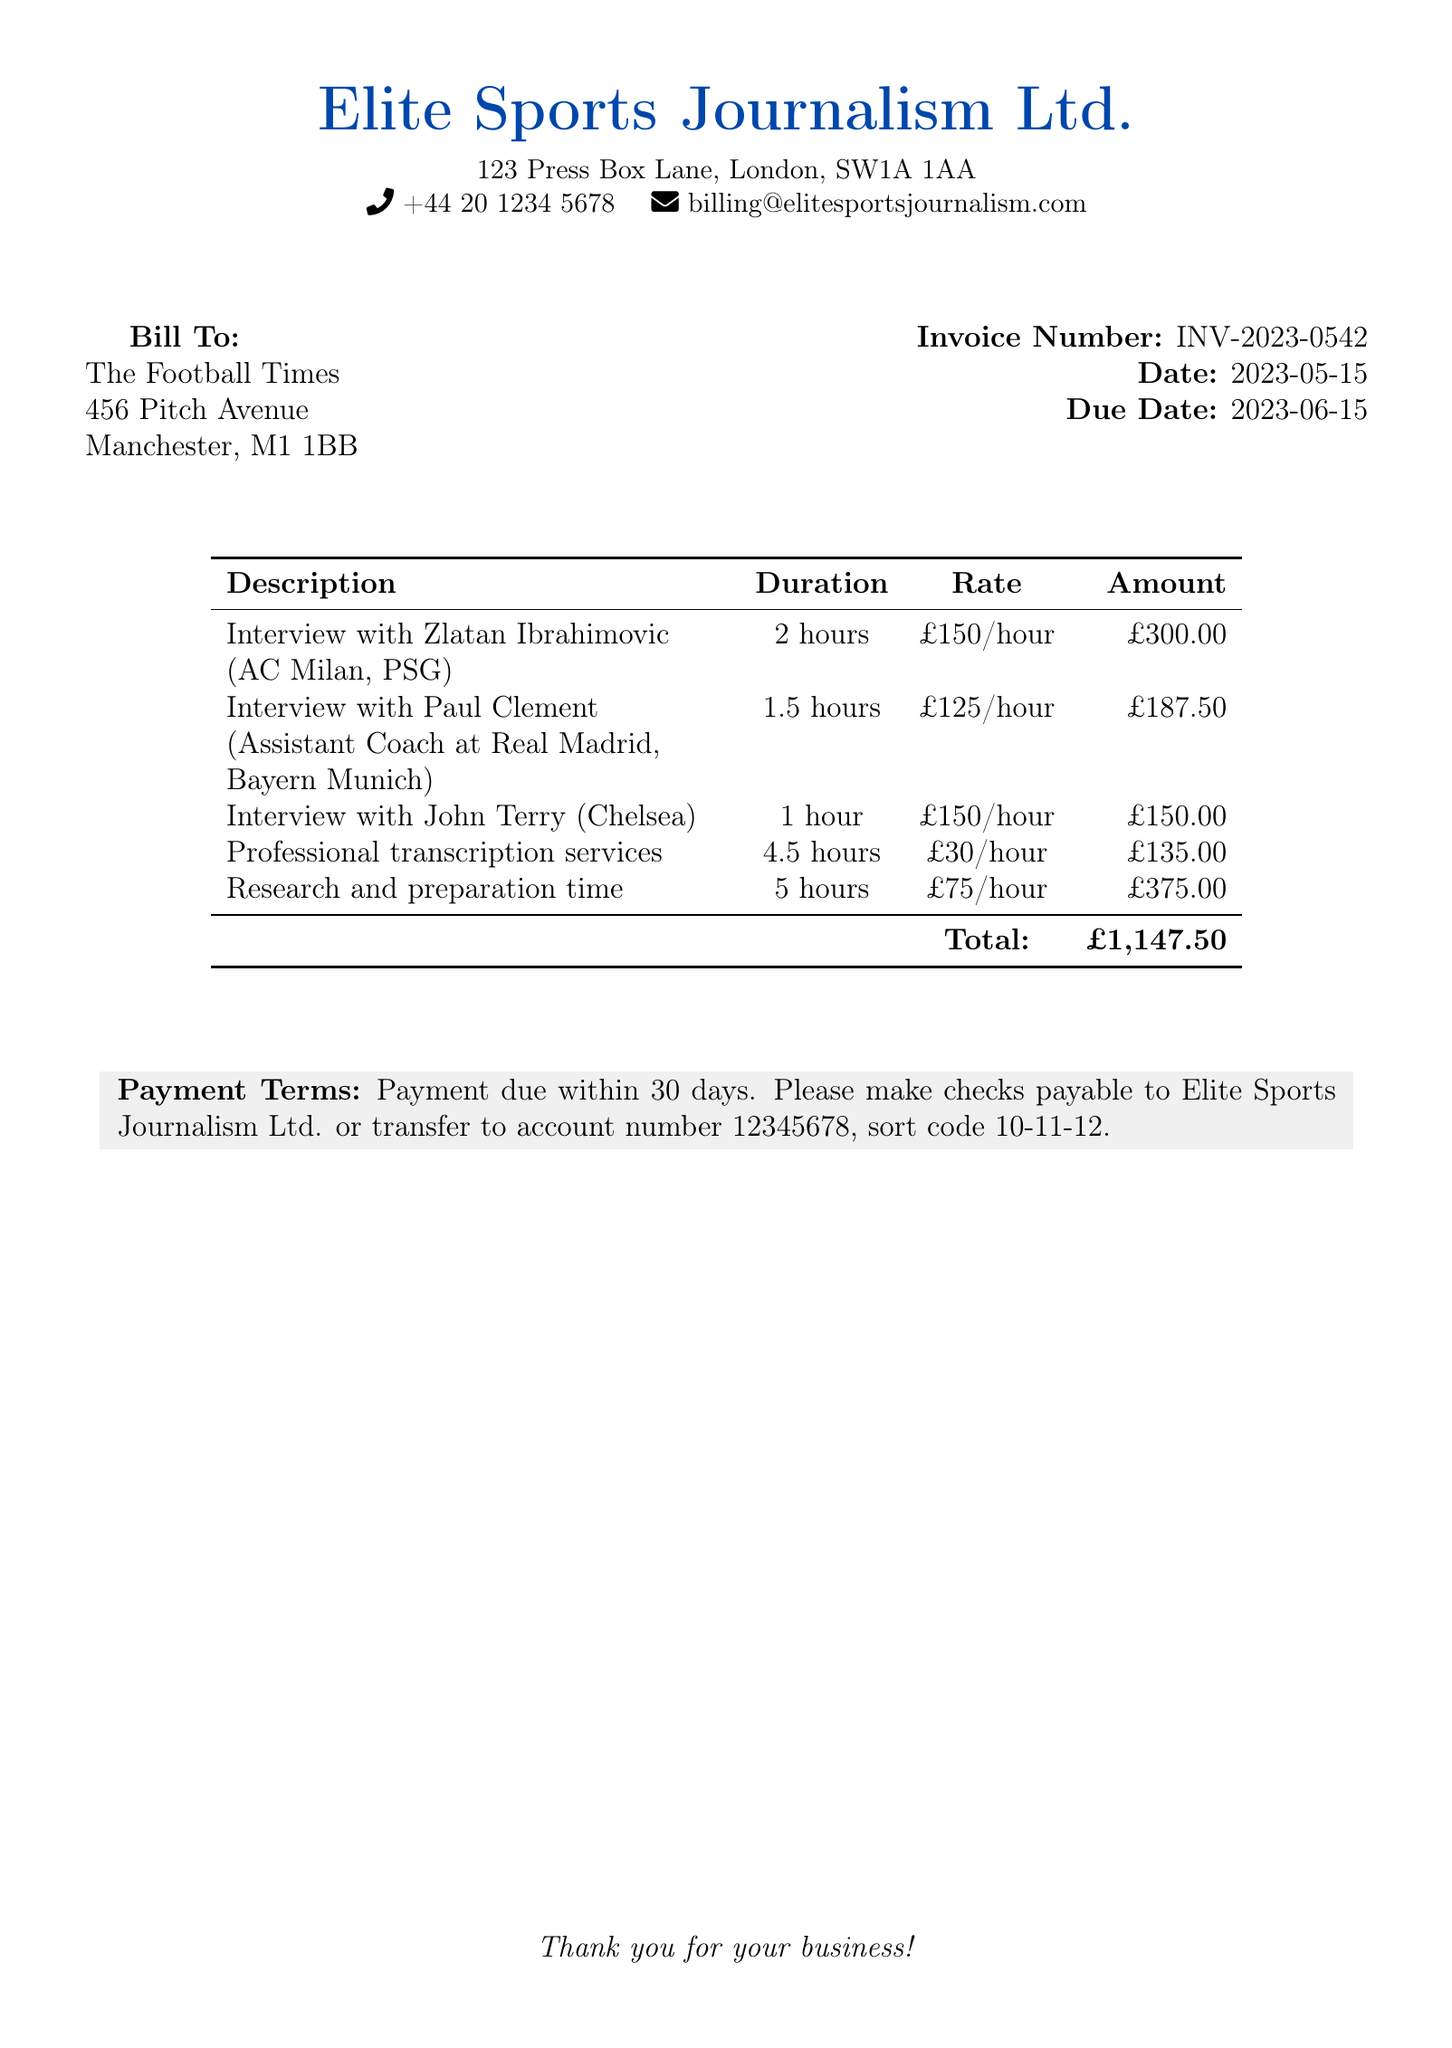What is the invoice number? The invoice number is specified in the document as a unique identifier for the billing, which is INV-2023-0542.
Answer: INV-2023-0542 What is the total amount due? The total amount due is calculated by summing all the costs associated with the interviews and services listed, which amounts to £1,147.50.
Answer: £1,147.50 Who is the bill addressed to? The bill is addressed to The Football Times, highlighting the recipient of the services provided.
Answer: The Football Times What is the rate for research and preparation time? The document specifies the rate charged for research and preparation time as £75 per hour, indicating the cost structure for this service.
Answer: £75/hour When is the payment due? The due date for payment is explicitly mentioned in the document, providing a deadline for when the payment should be made.
Answer: 2023-06-15 How long was the interview with Zlatan Ibrahimovic? The duration of the interview with Zlatan Ibrahimovic is noted in the document, giving specific time information for this service.
Answer: 2 hours What service has a total duration of 4.5 hours? The document outlines various services, with transcription services specifically listed as having a total duration of 4.5 hours.
Answer: Professional transcription services What is the payment term specified in the document? The payment term is stated to be a timeframe within which the recipients are expected to make the payment, detailed as 30 days.
Answer: 30 days 